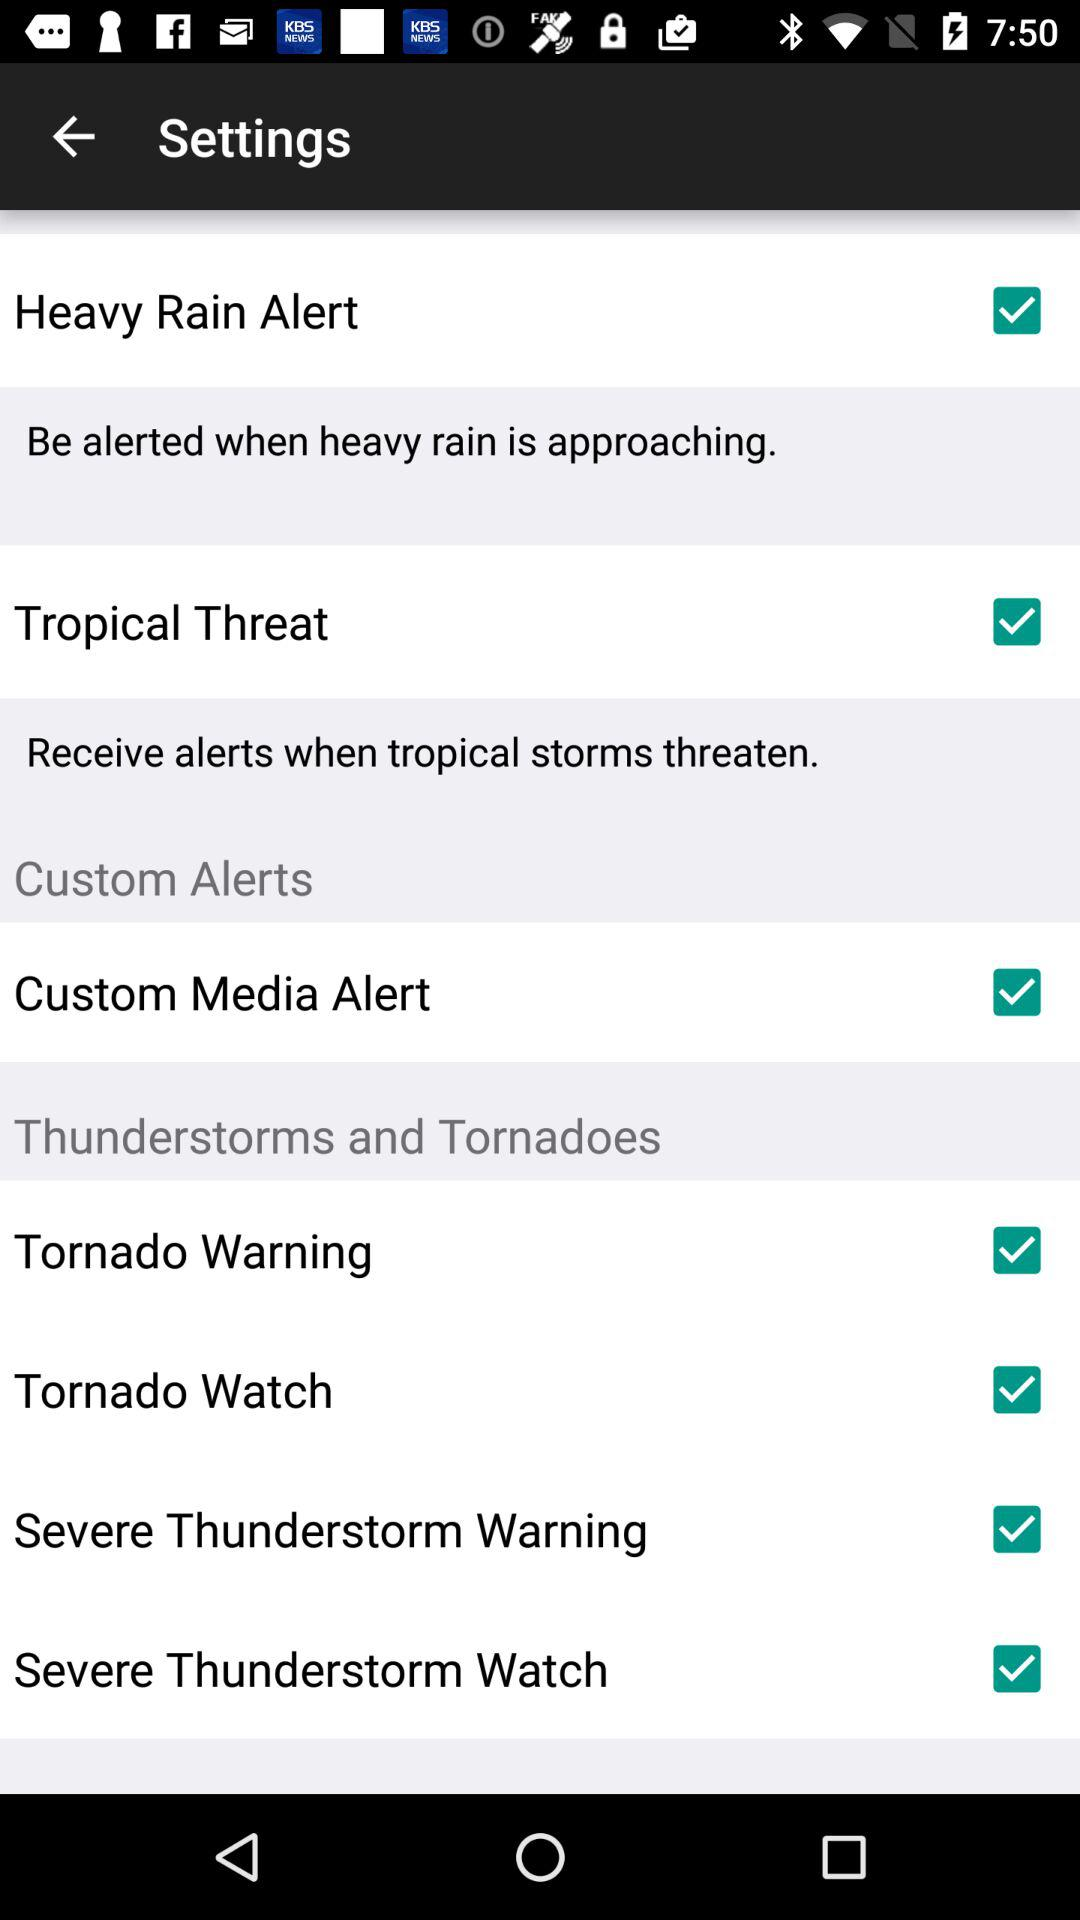What is the status of "Custom Media Alert"? The status is "on". 